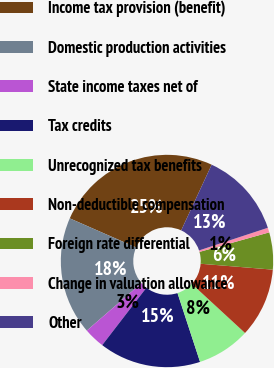<chart> <loc_0><loc_0><loc_500><loc_500><pie_chart><fcel>Income tax provision (benefit)<fcel>Domestic production activities<fcel>State income taxes net of<fcel>Tax credits<fcel>Unrecognized tax benefits<fcel>Non-deductible compensation<fcel>Foreign rate differential<fcel>Change in valuation allowance<fcel>Other<nl><fcel>25.33%<fcel>17.95%<fcel>3.18%<fcel>15.48%<fcel>8.1%<fcel>10.56%<fcel>5.64%<fcel>0.72%<fcel>13.02%<nl></chart> 